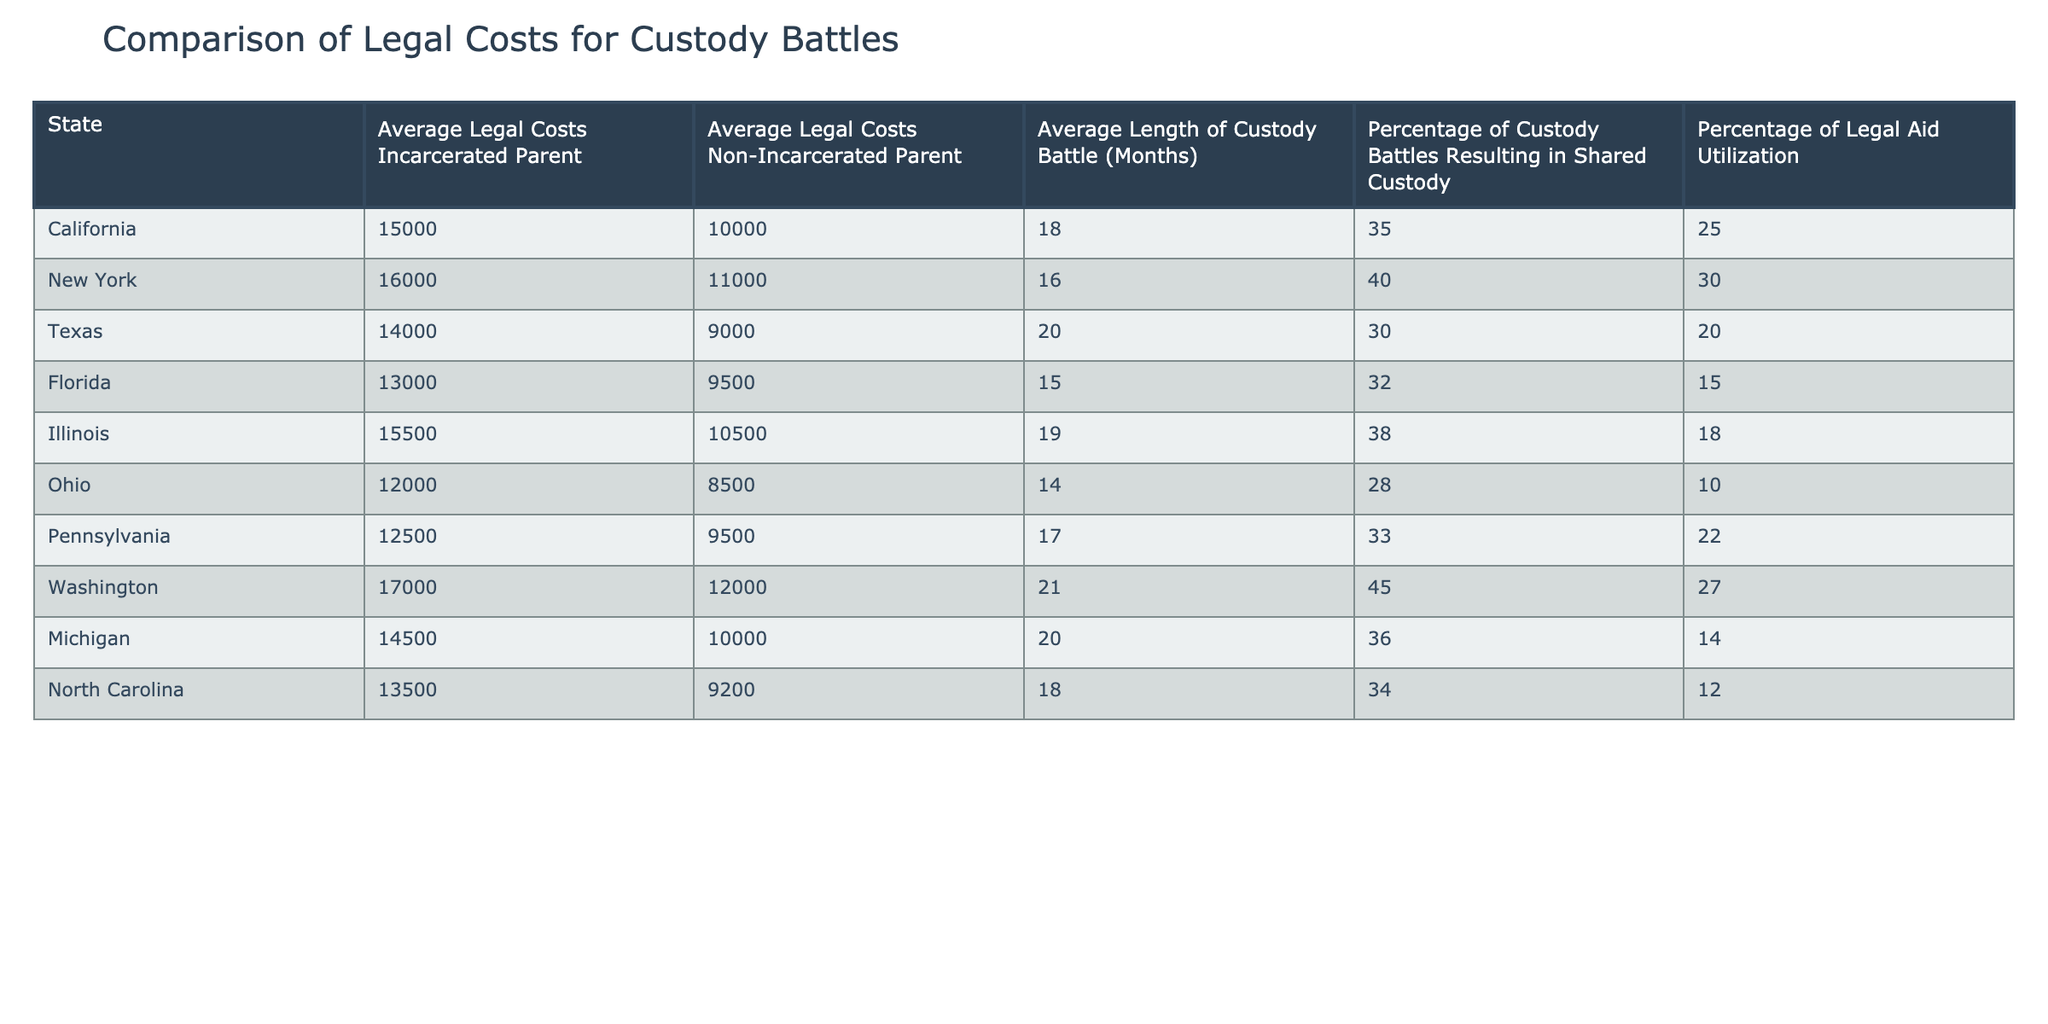What are the average legal costs for an incarcerated parent in Texas? From the table, I look for the row that indicates Texas. In that row, the average legal costs for an incarcerated parent are displayed as 14,000.
Answer: 14,000 Which state has the highest average legal costs for non-incarcerated parents? I check each state's average legal costs for non-incarcerated parents. The highest value is seen in New York, which shows 11,000.
Answer: 11,000 What is the average length of custody battles for incarcerated parents across all states? I need to calculate the average of the 'Average Length of Custody Battle (Months)' column by summing up the values (18 + 16 + 20 + 15 + 19 + 14 + 17 + 21 + 20 + 18) =  18.
Answer: 18 Is it true that the percentage of custody battles resulting in shared custody is higher for non-incarcerated parents in all states? I analyze the percentage of custody battles resulting in shared custody for both incarcerated and non-incarcerated parents. Upon reviewing the table, it shows that shared custody percentages for non-incarcerated parents are not consistently higher. For example, Washington has 45% for incarcerated versus 12,000 for non-incarcerated. Therefore, this statement is false.
Answer: No Calculate the difference in average legal costs between incarcerated and non-incarcerated parents in California. In California, the average legal costs for incarcerated parents are 15,000, while those for non-incarcerated parents are 10,000. The difference is computed as 15,000 - 10,000 = 5,000.
Answer: 5,000 Which state has the lowest percentage of legal aid utilization? I examine the 'Percentage of Legal Aid Utilization' column and find that Ohio has the lowest percentage at 10%.
Answer: Ohio What is the median average length of custody battles for both types of parents in the data? To find the median, I arrange the lengths for incarcerated parents: (14, 15, 16, 18, 18, 19, 20, 20, 21) results in 18. For non-incarcerated parents: (8, 9.5, 10, 11, 12, 12, 13.6, 14, 15) yields 12. The median lengths for both types are 18 and 12 months respectively.
Answer: 18 (incarcerated), 12 (non-incarcerated) Which state offers the shortest custody battles for incarcerated parents? I look for the minimum value in the 'Average Length of Custody Battle (Months)' for incarcerated parents. The shortest duration is found in Ohio, showing 14 months.
Answer: Ohio How many states have a shared custody rate above 35%? I will count the states with a shared custody rate over 35%. After checking the table, I find that California, New York, Illinois, Washington, and Michigan have rates above 35%, totaling 5 states.
Answer: 5 